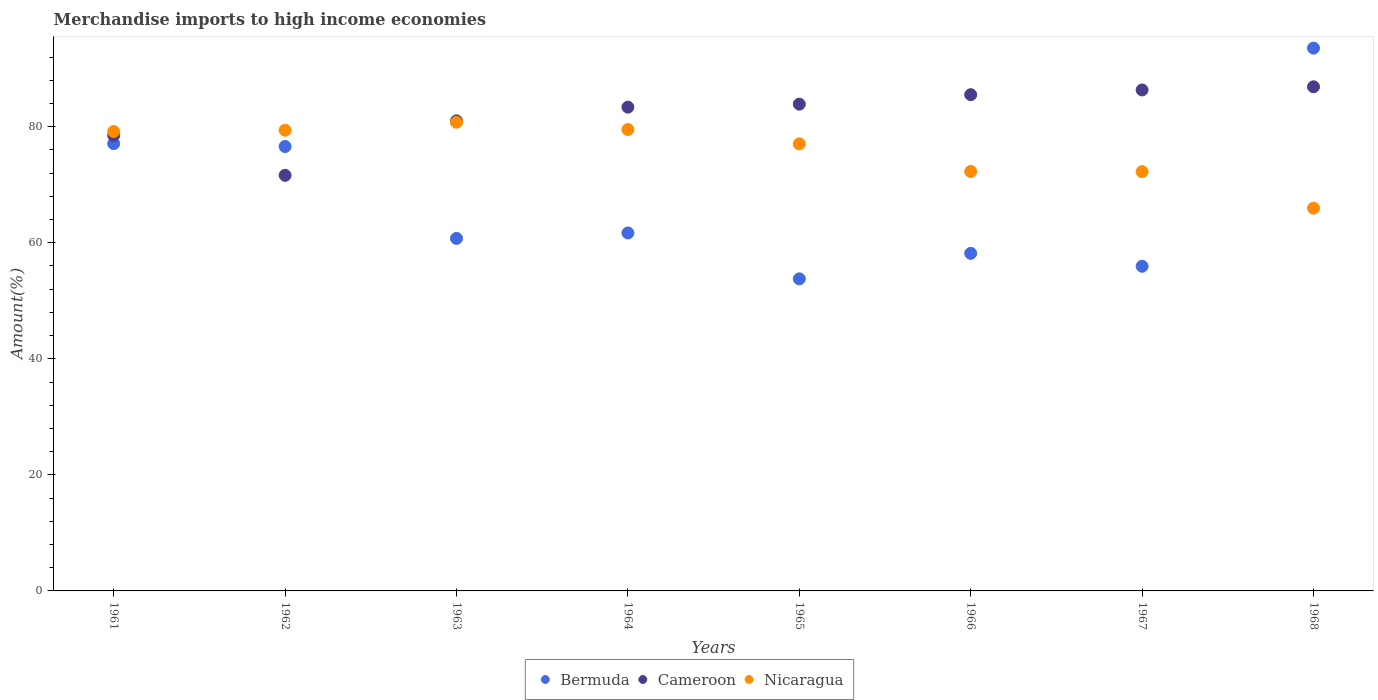What is the percentage of amount earned from merchandise imports in Cameroon in 1965?
Provide a succinct answer. 83.88. Across all years, what is the maximum percentage of amount earned from merchandise imports in Cameroon?
Provide a short and direct response. 86.87. Across all years, what is the minimum percentage of amount earned from merchandise imports in Bermuda?
Your answer should be very brief. 53.78. In which year was the percentage of amount earned from merchandise imports in Bermuda maximum?
Offer a terse response. 1968. In which year was the percentage of amount earned from merchandise imports in Bermuda minimum?
Ensure brevity in your answer.  1965. What is the total percentage of amount earned from merchandise imports in Bermuda in the graph?
Offer a very short reply. 537.51. What is the difference between the percentage of amount earned from merchandise imports in Bermuda in 1964 and that in 1968?
Offer a terse response. -31.85. What is the difference between the percentage of amount earned from merchandise imports in Cameroon in 1962 and the percentage of amount earned from merchandise imports in Nicaragua in 1964?
Make the answer very short. -7.89. What is the average percentage of amount earned from merchandise imports in Bermuda per year?
Offer a very short reply. 67.19. In the year 1965, what is the difference between the percentage of amount earned from merchandise imports in Nicaragua and percentage of amount earned from merchandise imports in Bermuda?
Your response must be concise. 23.25. What is the ratio of the percentage of amount earned from merchandise imports in Bermuda in 1962 to that in 1968?
Keep it short and to the point. 0.82. Is the percentage of amount earned from merchandise imports in Bermuda in 1965 less than that in 1967?
Your answer should be compact. Yes. Is the difference between the percentage of amount earned from merchandise imports in Nicaragua in 1965 and 1966 greater than the difference between the percentage of amount earned from merchandise imports in Bermuda in 1965 and 1966?
Your answer should be compact. Yes. What is the difference between the highest and the second highest percentage of amount earned from merchandise imports in Nicaragua?
Offer a terse response. 1.25. What is the difference between the highest and the lowest percentage of amount earned from merchandise imports in Nicaragua?
Give a very brief answer. 14.8. Is it the case that in every year, the sum of the percentage of amount earned from merchandise imports in Nicaragua and percentage of amount earned from merchandise imports in Bermuda  is greater than the percentage of amount earned from merchandise imports in Cameroon?
Give a very brief answer. Yes. Is the percentage of amount earned from merchandise imports in Cameroon strictly greater than the percentage of amount earned from merchandise imports in Bermuda over the years?
Your answer should be compact. No. Is the percentage of amount earned from merchandise imports in Nicaragua strictly less than the percentage of amount earned from merchandise imports in Cameroon over the years?
Provide a succinct answer. No. How many dotlines are there?
Your response must be concise. 3. What is the difference between two consecutive major ticks on the Y-axis?
Your answer should be very brief. 20. Does the graph contain grids?
Offer a very short reply. No. How many legend labels are there?
Your response must be concise. 3. What is the title of the graph?
Ensure brevity in your answer.  Merchandise imports to high income economies. What is the label or title of the Y-axis?
Offer a very short reply. Amount(%). What is the Amount(%) of Bermuda in 1961?
Give a very brief answer. 77.07. What is the Amount(%) of Cameroon in 1961?
Make the answer very short. 78.49. What is the Amount(%) of Nicaragua in 1961?
Give a very brief answer. 79.17. What is the Amount(%) in Bermuda in 1962?
Provide a succinct answer. 76.58. What is the Amount(%) of Cameroon in 1962?
Give a very brief answer. 71.61. What is the Amount(%) in Nicaragua in 1962?
Offer a very short reply. 79.39. What is the Amount(%) of Bermuda in 1963?
Your answer should be compact. 60.74. What is the Amount(%) in Cameroon in 1963?
Offer a terse response. 81. What is the Amount(%) of Nicaragua in 1963?
Give a very brief answer. 80.76. What is the Amount(%) of Bermuda in 1964?
Your answer should be compact. 61.68. What is the Amount(%) in Cameroon in 1964?
Make the answer very short. 83.36. What is the Amount(%) in Nicaragua in 1964?
Give a very brief answer. 79.5. What is the Amount(%) in Bermuda in 1965?
Keep it short and to the point. 53.78. What is the Amount(%) in Cameroon in 1965?
Your answer should be very brief. 83.88. What is the Amount(%) of Nicaragua in 1965?
Keep it short and to the point. 77.03. What is the Amount(%) in Bermuda in 1966?
Make the answer very short. 58.17. What is the Amount(%) of Cameroon in 1966?
Keep it short and to the point. 85.51. What is the Amount(%) in Nicaragua in 1966?
Ensure brevity in your answer.  72.28. What is the Amount(%) in Bermuda in 1967?
Offer a terse response. 55.94. What is the Amount(%) of Cameroon in 1967?
Your answer should be compact. 86.33. What is the Amount(%) in Nicaragua in 1967?
Make the answer very short. 72.25. What is the Amount(%) in Bermuda in 1968?
Offer a terse response. 93.54. What is the Amount(%) of Cameroon in 1968?
Offer a terse response. 86.87. What is the Amount(%) in Nicaragua in 1968?
Make the answer very short. 65.96. Across all years, what is the maximum Amount(%) in Bermuda?
Ensure brevity in your answer.  93.54. Across all years, what is the maximum Amount(%) in Cameroon?
Give a very brief answer. 86.87. Across all years, what is the maximum Amount(%) of Nicaragua?
Make the answer very short. 80.76. Across all years, what is the minimum Amount(%) of Bermuda?
Ensure brevity in your answer.  53.78. Across all years, what is the minimum Amount(%) of Cameroon?
Give a very brief answer. 71.61. Across all years, what is the minimum Amount(%) in Nicaragua?
Make the answer very short. 65.96. What is the total Amount(%) of Bermuda in the graph?
Provide a succinct answer. 537.51. What is the total Amount(%) in Cameroon in the graph?
Your answer should be very brief. 657.05. What is the total Amount(%) of Nicaragua in the graph?
Make the answer very short. 606.33. What is the difference between the Amount(%) in Bermuda in 1961 and that in 1962?
Offer a very short reply. 0.49. What is the difference between the Amount(%) of Cameroon in 1961 and that in 1962?
Ensure brevity in your answer.  6.88. What is the difference between the Amount(%) of Nicaragua in 1961 and that in 1962?
Your answer should be very brief. -0.22. What is the difference between the Amount(%) in Bermuda in 1961 and that in 1963?
Your response must be concise. 16.33. What is the difference between the Amount(%) of Cameroon in 1961 and that in 1963?
Make the answer very short. -2.51. What is the difference between the Amount(%) in Nicaragua in 1961 and that in 1963?
Your answer should be compact. -1.59. What is the difference between the Amount(%) of Bermuda in 1961 and that in 1964?
Offer a terse response. 15.39. What is the difference between the Amount(%) in Cameroon in 1961 and that in 1964?
Provide a short and direct response. -4.87. What is the difference between the Amount(%) of Nicaragua in 1961 and that in 1964?
Keep it short and to the point. -0.34. What is the difference between the Amount(%) of Bermuda in 1961 and that in 1965?
Offer a terse response. 23.3. What is the difference between the Amount(%) of Cameroon in 1961 and that in 1965?
Your answer should be compact. -5.39. What is the difference between the Amount(%) of Nicaragua in 1961 and that in 1965?
Provide a short and direct response. 2.14. What is the difference between the Amount(%) of Bermuda in 1961 and that in 1966?
Keep it short and to the point. 18.9. What is the difference between the Amount(%) of Cameroon in 1961 and that in 1966?
Provide a short and direct response. -7.02. What is the difference between the Amount(%) of Nicaragua in 1961 and that in 1966?
Make the answer very short. 6.89. What is the difference between the Amount(%) of Bermuda in 1961 and that in 1967?
Your answer should be very brief. 21.13. What is the difference between the Amount(%) in Cameroon in 1961 and that in 1967?
Your answer should be compact. -7.84. What is the difference between the Amount(%) in Nicaragua in 1961 and that in 1967?
Your answer should be very brief. 6.92. What is the difference between the Amount(%) of Bermuda in 1961 and that in 1968?
Ensure brevity in your answer.  -16.46. What is the difference between the Amount(%) of Cameroon in 1961 and that in 1968?
Keep it short and to the point. -8.38. What is the difference between the Amount(%) in Nicaragua in 1961 and that in 1968?
Your answer should be very brief. 13.21. What is the difference between the Amount(%) in Bermuda in 1962 and that in 1963?
Provide a short and direct response. 15.84. What is the difference between the Amount(%) of Cameroon in 1962 and that in 1963?
Keep it short and to the point. -9.39. What is the difference between the Amount(%) of Nicaragua in 1962 and that in 1963?
Keep it short and to the point. -1.37. What is the difference between the Amount(%) of Bermuda in 1962 and that in 1964?
Provide a succinct answer. 14.9. What is the difference between the Amount(%) of Cameroon in 1962 and that in 1964?
Ensure brevity in your answer.  -11.75. What is the difference between the Amount(%) in Nicaragua in 1962 and that in 1964?
Provide a short and direct response. -0.12. What is the difference between the Amount(%) of Bermuda in 1962 and that in 1965?
Give a very brief answer. 22.8. What is the difference between the Amount(%) in Cameroon in 1962 and that in 1965?
Your response must be concise. -12.27. What is the difference between the Amount(%) of Nicaragua in 1962 and that in 1965?
Offer a very short reply. 2.36. What is the difference between the Amount(%) in Bermuda in 1962 and that in 1966?
Provide a short and direct response. 18.41. What is the difference between the Amount(%) in Cameroon in 1962 and that in 1966?
Provide a short and direct response. -13.9. What is the difference between the Amount(%) of Nicaragua in 1962 and that in 1966?
Your answer should be very brief. 7.11. What is the difference between the Amount(%) in Bermuda in 1962 and that in 1967?
Keep it short and to the point. 20.64. What is the difference between the Amount(%) of Cameroon in 1962 and that in 1967?
Make the answer very short. -14.72. What is the difference between the Amount(%) of Nicaragua in 1962 and that in 1967?
Keep it short and to the point. 7.14. What is the difference between the Amount(%) in Bermuda in 1962 and that in 1968?
Give a very brief answer. -16.95. What is the difference between the Amount(%) of Cameroon in 1962 and that in 1968?
Provide a short and direct response. -15.26. What is the difference between the Amount(%) in Nicaragua in 1962 and that in 1968?
Your response must be concise. 13.43. What is the difference between the Amount(%) in Bermuda in 1963 and that in 1964?
Keep it short and to the point. -0.94. What is the difference between the Amount(%) of Cameroon in 1963 and that in 1964?
Offer a terse response. -2.36. What is the difference between the Amount(%) of Nicaragua in 1963 and that in 1964?
Keep it short and to the point. 1.25. What is the difference between the Amount(%) of Bermuda in 1963 and that in 1965?
Make the answer very short. 6.97. What is the difference between the Amount(%) of Cameroon in 1963 and that in 1965?
Offer a terse response. -2.88. What is the difference between the Amount(%) of Nicaragua in 1963 and that in 1965?
Offer a terse response. 3.73. What is the difference between the Amount(%) in Bermuda in 1963 and that in 1966?
Give a very brief answer. 2.57. What is the difference between the Amount(%) of Cameroon in 1963 and that in 1966?
Offer a terse response. -4.51. What is the difference between the Amount(%) of Nicaragua in 1963 and that in 1966?
Offer a very short reply. 8.48. What is the difference between the Amount(%) of Bermuda in 1963 and that in 1967?
Keep it short and to the point. 4.8. What is the difference between the Amount(%) of Cameroon in 1963 and that in 1967?
Offer a terse response. -5.33. What is the difference between the Amount(%) of Nicaragua in 1963 and that in 1967?
Your response must be concise. 8.51. What is the difference between the Amount(%) in Bermuda in 1963 and that in 1968?
Offer a terse response. -32.79. What is the difference between the Amount(%) of Cameroon in 1963 and that in 1968?
Your response must be concise. -5.87. What is the difference between the Amount(%) of Nicaragua in 1963 and that in 1968?
Keep it short and to the point. 14.8. What is the difference between the Amount(%) of Bermuda in 1964 and that in 1965?
Keep it short and to the point. 7.9. What is the difference between the Amount(%) of Cameroon in 1964 and that in 1965?
Provide a succinct answer. -0.52. What is the difference between the Amount(%) of Nicaragua in 1964 and that in 1965?
Keep it short and to the point. 2.48. What is the difference between the Amount(%) in Bermuda in 1964 and that in 1966?
Provide a short and direct response. 3.51. What is the difference between the Amount(%) of Cameroon in 1964 and that in 1966?
Provide a succinct answer. -2.15. What is the difference between the Amount(%) in Nicaragua in 1964 and that in 1966?
Your response must be concise. 7.23. What is the difference between the Amount(%) of Bermuda in 1964 and that in 1967?
Your response must be concise. 5.74. What is the difference between the Amount(%) of Cameroon in 1964 and that in 1967?
Make the answer very short. -2.97. What is the difference between the Amount(%) in Nicaragua in 1964 and that in 1967?
Your response must be concise. 7.25. What is the difference between the Amount(%) in Bermuda in 1964 and that in 1968?
Give a very brief answer. -31.86. What is the difference between the Amount(%) in Cameroon in 1964 and that in 1968?
Provide a short and direct response. -3.51. What is the difference between the Amount(%) of Nicaragua in 1964 and that in 1968?
Your answer should be compact. 13.55. What is the difference between the Amount(%) of Bermuda in 1965 and that in 1966?
Your response must be concise. -4.39. What is the difference between the Amount(%) in Cameroon in 1965 and that in 1966?
Your response must be concise. -1.63. What is the difference between the Amount(%) of Nicaragua in 1965 and that in 1966?
Give a very brief answer. 4.75. What is the difference between the Amount(%) of Bermuda in 1965 and that in 1967?
Ensure brevity in your answer.  -2.17. What is the difference between the Amount(%) of Cameroon in 1965 and that in 1967?
Your answer should be compact. -2.45. What is the difference between the Amount(%) of Nicaragua in 1965 and that in 1967?
Keep it short and to the point. 4.78. What is the difference between the Amount(%) in Bermuda in 1965 and that in 1968?
Your answer should be very brief. -39.76. What is the difference between the Amount(%) of Cameroon in 1965 and that in 1968?
Ensure brevity in your answer.  -2.99. What is the difference between the Amount(%) of Nicaragua in 1965 and that in 1968?
Offer a very short reply. 11.07. What is the difference between the Amount(%) of Bermuda in 1966 and that in 1967?
Offer a very short reply. 2.23. What is the difference between the Amount(%) of Cameroon in 1966 and that in 1967?
Provide a short and direct response. -0.82. What is the difference between the Amount(%) of Nicaragua in 1966 and that in 1967?
Make the answer very short. 0.03. What is the difference between the Amount(%) of Bermuda in 1966 and that in 1968?
Your answer should be compact. -35.37. What is the difference between the Amount(%) of Cameroon in 1966 and that in 1968?
Your answer should be very brief. -1.36. What is the difference between the Amount(%) in Nicaragua in 1966 and that in 1968?
Your answer should be compact. 6.32. What is the difference between the Amount(%) of Bermuda in 1967 and that in 1968?
Keep it short and to the point. -37.59. What is the difference between the Amount(%) of Cameroon in 1967 and that in 1968?
Offer a terse response. -0.54. What is the difference between the Amount(%) of Nicaragua in 1967 and that in 1968?
Provide a succinct answer. 6.29. What is the difference between the Amount(%) in Bermuda in 1961 and the Amount(%) in Cameroon in 1962?
Provide a short and direct response. 5.46. What is the difference between the Amount(%) in Bermuda in 1961 and the Amount(%) in Nicaragua in 1962?
Your answer should be compact. -2.31. What is the difference between the Amount(%) in Cameroon in 1961 and the Amount(%) in Nicaragua in 1962?
Make the answer very short. -0.9. What is the difference between the Amount(%) of Bermuda in 1961 and the Amount(%) of Cameroon in 1963?
Offer a terse response. -3.93. What is the difference between the Amount(%) of Bermuda in 1961 and the Amount(%) of Nicaragua in 1963?
Ensure brevity in your answer.  -3.68. What is the difference between the Amount(%) in Cameroon in 1961 and the Amount(%) in Nicaragua in 1963?
Give a very brief answer. -2.27. What is the difference between the Amount(%) of Bermuda in 1961 and the Amount(%) of Cameroon in 1964?
Offer a terse response. -6.29. What is the difference between the Amount(%) in Bermuda in 1961 and the Amount(%) in Nicaragua in 1964?
Give a very brief answer. -2.43. What is the difference between the Amount(%) in Cameroon in 1961 and the Amount(%) in Nicaragua in 1964?
Offer a very short reply. -1.01. What is the difference between the Amount(%) of Bermuda in 1961 and the Amount(%) of Cameroon in 1965?
Your response must be concise. -6.8. What is the difference between the Amount(%) of Bermuda in 1961 and the Amount(%) of Nicaragua in 1965?
Give a very brief answer. 0.05. What is the difference between the Amount(%) of Cameroon in 1961 and the Amount(%) of Nicaragua in 1965?
Offer a very short reply. 1.46. What is the difference between the Amount(%) of Bermuda in 1961 and the Amount(%) of Cameroon in 1966?
Offer a terse response. -8.43. What is the difference between the Amount(%) in Bermuda in 1961 and the Amount(%) in Nicaragua in 1966?
Make the answer very short. 4.8. What is the difference between the Amount(%) of Cameroon in 1961 and the Amount(%) of Nicaragua in 1966?
Offer a terse response. 6.21. What is the difference between the Amount(%) in Bermuda in 1961 and the Amount(%) in Cameroon in 1967?
Keep it short and to the point. -9.25. What is the difference between the Amount(%) in Bermuda in 1961 and the Amount(%) in Nicaragua in 1967?
Your response must be concise. 4.83. What is the difference between the Amount(%) of Cameroon in 1961 and the Amount(%) of Nicaragua in 1967?
Your answer should be very brief. 6.24. What is the difference between the Amount(%) of Bermuda in 1961 and the Amount(%) of Cameroon in 1968?
Your answer should be compact. -9.8. What is the difference between the Amount(%) in Bermuda in 1961 and the Amount(%) in Nicaragua in 1968?
Provide a short and direct response. 11.12. What is the difference between the Amount(%) of Cameroon in 1961 and the Amount(%) of Nicaragua in 1968?
Ensure brevity in your answer.  12.53. What is the difference between the Amount(%) of Bermuda in 1962 and the Amount(%) of Cameroon in 1963?
Provide a succinct answer. -4.42. What is the difference between the Amount(%) of Bermuda in 1962 and the Amount(%) of Nicaragua in 1963?
Provide a short and direct response. -4.18. What is the difference between the Amount(%) of Cameroon in 1962 and the Amount(%) of Nicaragua in 1963?
Provide a short and direct response. -9.15. What is the difference between the Amount(%) in Bermuda in 1962 and the Amount(%) in Cameroon in 1964?
Offer a terse response. -6.78. What is the difference between the Amount(%) in Bermuda in 1962 and the Amount(%) in Nicaragua in 1964?
Your answer should be very brief. -2.92. What is the difference between the Amount(%) in Cameroon in 1962 and the Amount(%) in Nicaragua in 1964?
Keep it short and to the point. -7.89. What is the difference between the Amount(%) in Bermuda in 1962 and the Amount(%) in Cameroon in 1965?
Give a very brief answer. -7.29. What is the difference between the Amount(%) of Bermuda in 1962 and the Amount(%) of Nicaragua in 1965?
Your answer should be compact. -0.45. What is the difference between the Amount(%) in Cameroon in 1962 and the Amount(%) in Nicaragua in 1965?
Your answer should be compact. -5.42. What is the difference between the Amount(%) of Bermuda in 1962 and the Amount(%) of Cameroon in 1966?
Ensure brevity in your answer.  -8.92. What is the difference between the Amount(%) of Bermuda in 1962 and the Amount(%) of Nicaragua in 1966?
Your response must be concise. 4.31. What is the difference between the Amount(%) in Cameroon in 1962 and the Amount(%) in Nicaragua in 1966?
Ensure brevity in your answer.  -0.67. What is the difference between the Amount(%) of Bermuda in 1962 and the Amount(%) of Cameroon in 1967?
Provide a short and direct response. -9.74. What is the difference between the Amount(%) in Bermuda in 1962 and the Amount(%) in Nicaragua in 1967?
Your answer should be very brief. 4.33. What is the difference between the Amount(%) in Cameroon in 1962 and the Amount(%) in Nicaragua in 1967?
Ensure brevity in your answer.  -0.64. What is the difference between the Amount(%) in Bermuda in 1962 and the Amount(%) in Cameroon in 1968?
Provide a short and direct response. -10.29. What is the difference between the Amount(%) in Bermuda in 1962 and the Amount(%) in Nicaragua in 1968?
Offer a terse response. 10.63. What is the difference between the Amount(%) in Cameroon in 1962 and the Amount(%) in Nicaragua in 1968?
Keep it short and to the point. 5.65. What is the difference between the Amount(%) in Bermuda in 1963 and the Amount(%) in Cameroon in 1964?
Your answer should be compact. -22.62. What is the difference between the Amount(%) of Bermuda in 1963 and the Amount(%) of Nicaragua in 1964?
Your response must be concise. -18.76. What is the difference between the Amount(%) of Cameroon in 1963 and the Amount(%) of Nicaragua in 1964?
Make the answer very short. 1.5. What is the difference between the Amount(%) in Bermuda in 1963 and the Amount(%) in Cameroon in 1965?
Keep it short and to the point. -23.13. What is the difference between the Amount(%) in Bermuda in 1963 and the Amount(%) in Nicaragua in 1965?
Provide a succinct answer. -16.28. What is the difference between the Amount(%) in Cameroon in 1963 and the Amount(%) in Nicaragua in 1965?
Keep it short and to the point. 3.97. What is the difference between the Amount(%) in Bermuda in 1963 and the Amount(%) in Cameroon in 1966?
Keep it short and to the point. -24.76. What is the difference between the Amount(%) of Bermuda in 1963 and the Amount(%) of Nicaragua in 1966?
Give a very brief answer. -11.53. What is the difference between the Amount(%) of Cameroon in 1963 and the Amount(%) of Nicaragua in 1966?
Your answer should be very brief. 8.72. What is the difference between the Amount(%) of Bermuda in 1963 and the Amount(%) of Cameroon in 1967?
Your response must be concise. -25.58. What is the difference between the Amount(%) of Bermuda in 1963 and the Amount(%) of Nicaragua in 1967?
Provide a succinct answer. -11.51. What is the difference between the Amount(%) of Cameroon in 1963 and the Amount(%) of Nicaragua in 1967?
Ensure brevity in your answer.  8.75. What is the difference between the Amount(%) of Bermuda in 1963 and the Amount(%) of Cameroon in 1968?
Your answer should be compact. -26.13. What is the difference between the Amount(%) of Bermuda in 1963 and the Amount(%) of Nicaragua in 1968?
Keep it short and to the point. -5.21. What is the difference between the Amount(%) in Cameroon in 1963 and the Amount(%) in Nicaragua in 1968?
Offer a very short reply. 15.04. What is the difference between the Amount(%) in Bermuda in 1964 and the Amount(%) in Cameroon in 1965?
Offer a very short reply. -22.2. What is the difference between the Amount(%) in Bermuda in 1964 and the Amount(%) in Nicaragua in 1965?
Your answer should be very brief. -15.35. What is the difference between the Amount(%) of Cameroon in 1964 and the Amount(%) of Nicaragua in 1965?
Your response must be concise. 6.33. What is the difference between the Amount(%) of Bermuda in 1964 and the Amount(%) of Cameroon in 1966?
Ensure brevity in your answer.  -23.83. What is the difference between the Amount(%) in Bermuda in 1964 and the Amount(%) in Nicaragua in 1966?
Give a very brief answer. -10.6. What is the difference between the Amount(%) of Cameroon in 1964 and the Amount(%) of Nicaragua in 1966?
Offer a very short reply. 11.08. What is the difference between the Amount(%) of Bermuda in 1964 and the Amount(%) of Cameroon in 1967?
Your answer should be very brief. -24.65. What is the difference between the Amount(%) of Bermuda in 1964 and the Amount(%) of Nicaragua in 1967?
Provide a succinct answer. -10.57. What is the difference between the Amount(%) of Cameroon in 1964 and the Amount(%) of Nicaragua in 1967?
Make the answer very short. 11.11. What is the difference between the Amount(%) in Bermuda in 1964 and the Amount(%) in Cameroon in 1968?
Your answer should be compact. -25.19. What is the difference between the Amount(%) in Bermuda in 1964 and the Amount(%) in Nicaragua in 1968?
Keep it short and to the point. -4.28. What is the difference between the Amount(%) of Cameroon in 1964 and the Amount(%) of Nicaragua in 1968?
Keep it short and to the point. 17.4. What is the difference between the Amount(%) in Bermuda in 1965 and the Amount(%) in Cameroon in 1966?
Give a very brief answer. -31.73. What is the difference between the Amount(%) in Bermuda in 1965 and the Amount(%) in Nicaragua in 1966?
Offer a very short reply. -18.5. What is the difference between the Amount(%) in Cameroon in 1965 and the Amount(%) in Nicaragua in 1966?
Make the answer very short. 11.6. What is the difference between the Amount(%) in Bermuda in 1965 and the Amount(%) in Cameroon in 1967?
Your answer should be compact. -32.55. What is the difference between the Amount(%) in Bermuda in 1965 and the Amount(%) in Nicaragua in 1967?
Your response must be concise. -18.47. What is the difference between the Amount(%) in Cameroon in 1965 and the Amount(%) in Nicaragua in 1967?
Keep it short and to the point. 11.63. What is the difference between the Amount(%) of Bermuda in 1965 and the Amount(%) of Cameroon in 1968?
Your answer should be very brief. -33.09. What is the difference between the Amount(%) of Bermuda in 1965 and the Amount(%) of Nicaragua in 1968?
Keep it short and to the point. -12.18. What is the difference between the Amount(%) in Cameroon in 1965 and the Amount(%) in Nicaragua in 1968?
Provide a short and direct response. 17.92. What is the difference between the Amount(%) of Bermuda in 1966 and the Amount(%) of Cameroon in 1967?
Ensure brevity in your answer.  -28.16. What is the difference between the Amount(%) in Bermuda in 1966 and the Amount(%) in Nicaragua in 1967?
Provide a succinct answer. -14.08. What is the difference between the Amount(%) in Cameroon in 1966 and the Amount(%) in Nicaragua in 1967?
Ensure brevity in your answer.  13.26. What is the difference between the Amount(%) of Bermuda in 1966 and the Amount(%) of Cameroon in 1968?
Offer a terse response. -28.7. What is the difference between the Amount(%) of Bermuda in 1966 and the Amount(%) of Nicaragua in 1968?
Your answer should be compact. -7.79. What is the difference between the Amount(%) in Cameroon in 1966 and the Amount(%) in Nicaragua in 1968?
Keep it short and to the point. 19.55. What is the difference between the Amount(%) in Bermuda in 1967 and the Amount(%) in Cameroon in 1968?
Your answer should be compact. -30.93. What is the difference between the Amount(%) of Bermuda in 1967 and the Amount(%) of Nicaragua in 1968?
Provide a succinct answer. -10.01. What is the difference between the Amount(%) of Cameroon in 1967 and the Amount(%) of Nicaragua in 1968?
Ensure brevity in your answer.  20.37. What is the average Amount(%) in Bermuda per year?
Provide a short and direct response. 67.19. What is the average Amount(%) in Cameroon per year?
Ensure brevity in your answer.  82.13. What is the average Amount(%) of Nicaragua per year?
Give a very brief answer. 75.79. In the year 1961, what is the difference between the Amount(%) of Bermuda and Amount(%) of Cameroon?
Your answer should be compact. -1.41. In the year 1961, what is the difference between the Amount(%) in Bermuda and Amount(%) in Nicaragua?
Make the answer very short. -2.09. In the year 1961, what is the difference between the Amount(%) of Cameroon and Amount(%) of Nicaragua?
Your answer should be very brief. -0.68. In the year 1962, what is the difference between the Amount(%) of Bermuda and Amount(%) of Cameroon?
Keep it short and to the point. 4.97. In the year 1962, what is the difference between the Amount(%) in Bermuda and Amount(%) in Nicaragua?
Offer a terse response. -2.8. In the year 1962, what is the difference between the Amount(%) of Cameroon and Amount(%) of Nicaragua?
Provide a short and direct response. -7.78. In the year 1963, what is the difference between the Amount(%) of Bermuda and Amount(%) of Cameroon?
Offer a terse response. -20.26. In the year 1963, what is the difference between the Amount(%) in Bermuda and Amount(%) in Nicaragua?
Your response must be concise. -20.01. In the year 1963, what is the difference between the Amount(%) in Cameroon and Amount(%) in Nicaragua?
Make the answer very short. 0.24. In the year 1964, what is the difference between the Amount(%) in Bermuda and Amount(%) in Cameroon?
Offer a very short reply. -21.68. In the year 1964, what is the difference between the Amount(%) of Bermuda and Amount(%) of Nicaragua?
Make the answer very short. -17.82. In the year 1964, what is the difference between the Amount(%) in Cameroon and Amount(%) in Nicaragua?
Provide a short and direct response. 3.86. In the year 1965, what is the difference between the Amount(%) of Bermuda and Amount(%) of Cameroon?
Your answer should be very brief. -30.1. In the year 1965, what is the difference between the Amount(%) of Bermuda and Amount(%) of Nicaragua?
Give a very brief answer. -23.25. In the year 1965, what is the difference between the Amount(%) in Cameroon and Amount(%) in Nicaragua?
Provide a short and direct response. 6.85. In the year 1966, what is the difference between the Amount(%) of Bermuda and Amount(%) of Cameroon?
Your response must be concise. -27.34. In the year 1966, what is the difference between the Amount(%) of Bermuda and Amount(%) of Nicaragua?
Give a very brief answer. -14.11. In the year 1966, what is the difference between the Amount(%) in Cameroon and Amount(%) in Nicaragua?
Your answer should be very brief. 13.23. In the year 1967, what is the difference between the Amount(%) of Bermuda and Amount(%) of Cameroon?
Offer a very short reply. -30.38. In the year 1967, what is the difference between the Amount(%) in Bermuda and Amount(%) in Nicaragua?
Make the answer very short. -16.31. In the year 1967, what is the difference between the Amount(%) of Cameroon and Amount(%) of Nicaragua?
Make the answer very short. 14.08. In the year 1968, what is the difference between the Amount(%) of Bermuda and Amount(%) of Cameroon?
Offer a terse response. 6.66. In the year 1968, what is the difference between the Amount(%) in Bermuda and Amount(%) in Nicaragua?
Give a very brief answer. 27.58. In the year 1968, what is the difference between the Amount(%) in Cameroon and Amount(%) in Nicaragua?
Your answer should be very brief. 20.91. What is the ratio of the Amount(%) of Bermuda in 1961 to that in 1962?
Your answer should be very brief. 1.01. What is the ratio of the Amount(%) in Cameroon in 1961 to that in 1962?
Your answer should be compact. 1.1. What is the ratio of the Amount(%) in Bermuda in 1961 to that in 1963?
Give a very brief answer. 1.27. What is the ratio of the Amount(%) in Cameroon in 1961 to that in 1963?
Offer a very short reply. 0.97. What is the ratio of the Amount(%) of Nicaragua in 1961 to that in 1963?
Ensure brevity in your answer.  0.98. What is the ratio of the Amount(%) of Bermuda in 1961 to that in 1964?
Your response must be concise. 1.25. What is the ratio of the Amount(%) of Cameroon in 1961 to that in 1964?
Provide a succinct answer. 0.94. What is the ratio of the Amount(%) in Bermuda in 1961 to that in 1965?
Ensure brevity in your answer.  1.43. What is the ratio of the Amount(%) of Cameroon in 1961 to that in 1965?
Give a very brief answer. 0.94. What is the ratio of the Amount(%) in Nicaragua in 1961 to that in 1965?
Your response must be concise. 1.03. What is the ratio of the Amount(%) in Bermuda in 1961 to that in 1966?
Offer a very short reply. 1.32. What is the ratio of the Amount(%) of Cameroon in 1961 to that in 1966?
Ensure brevity in your answer.  0.92. What is the ratio of the Amount(%) of Nicaragua in 1961 to that in 1966?
Offer a terse response. 1.1. What is the ratio of the Amount(%) of Bermuda in 1961 to that in 1967?
Offer a very short reply. 1.38. What is the ratio of the Amount(%) in Cameroon in 1961 to that in 1967?
Provide a succinct answer. 0.91. What is the ratio of the Amount(%) of Nicaragua in 1961 to that in 1967?
Give a very brief answer. 1.1. What is the ratio of the Amount(%) in Bermuda in 1961 to that in 1968?
Provide a succinct answer. 0.82. What is the ratio of the Amount(%) of Cameroon in 1961 to that in 1968?
Provide a short and direct response. 0.9. What is the ratio of the Amount(%) in Nicaragua in 1961 to that in 1968?
Your answer should be compact. 1.2. What is the ratio of the Amount(%) of Bermuda in 1962 to that in 1963?
Your answer should be compact. 1.26. What is the ratio of the Amount(%) of Cameroon in 1962 to that in 1963?
Make the answer very short. 0.88. What is the ratio of the Amount(%) in Bermuda in 1962 to that in 1964?
Keep it short and to the point. 1.24. What is the ratio of the Amount(%) in Cameroon in 1962 to that in 1964?
Keep it short and to the point. 0.86. What is the ratio of the Amount(%) of Nicaragua in 1962 to that in 1964?
Keep it short and to the point. 1. What is the ratio of the Amount(%) of Bermuda in 1962 to that in 1965?
Your answer should be compact. 1.42. What is the ratio of the Amount(%) of Cameroon in 1962 to that in 1965?
Provide a succinct answer. 0.85. What is the ratio of the Amount(%) of Nicaragua in 1962 to that in 1965?
Keep it short and to the point. 1.03. What is the ratio of the Amount(%) of Bermuda in 1962 to that in 1966?
Provide a short and direct response. 1.32. What is the ratio of the Amount(%) of Cameroon in 1962 to that in 1966?
Give a very brief answer. 0.84. What is the ratio of the Amount(%) in Nicaragua in 1962 to that in 1966?
Offer a terse response. 1.1. What is the ratio of the Amount(%) in Bermuda in 1962 to that in 1967?
Make the answer very short. 1.37. What is the ratio of the Amount(%) of Cameroon in 1962 to that in 1967?
Offer a terse response. 0.83. What is the ratio of the Amount(%) in Nicaragua in 1962 to that in 1967?
Keep it short and to the point. 1.1. What is the ratio of the Amount(%) of Bermuda in 1962 to that in 1968?
Provide a succinct answer. 0.82. What is the ratio of the Amount(%) in Cameroon in 1962 to that in 1968?
Provide a short and direct response. 0.82. What is the ratio of the Amount(%) of Nicaragua in 1962 to that in 1968?
Offer a terse response. 1.2. What is the ratio of the Amount(%) of Bermuda in 1963 to that in 1964?
Provide a succinct answer. 0.98. What is the ratio of the Amount(%) of Cameroon in 1963 to that in 1964?
Your response must be concise. 0.97. What is the ratio of the Amount(%) of Nicaragua in 1963 to that in 1964?
Ensure brevity in your answer.  1.02. What is the ratio of the Amount(%) of Bermuda in 1963 to that in 1965?
Make the answer very short. 1.13. What is the ratio of the Amount(%) of Cameroon in 1963 to that in 1965?
Your answer should be compact. 0.97. What is the ratio of the Amount(%) of Nicaragua in 1963 to that in 1965?
Keep it short and to the point. 1.05. What is the ratio of the Amount(%) of Bermuda in 1963 to that in 1966?
Offer a terse response. 1.04. What is the ratio of the Amount(%) of Cameroon in 1963 to that in 1966?
Provide a short and direct response. 0.95. What is the ratio of the Amount(%) in Nicaragua in 1963 to that in 1966?
Your response must be concise. 1.12. What is the ratio of the Amount(%) of Bermuda in 1963 to that in 1967?
Ensure brevity in your answer.  1.09. What is the ratio of the Amount(%) in Cameroon in 1963 to that in 1967?
Provide a succinct answer. 0.94. What is the ratio of the Amount(%) of Nicaragua in 1963 to that in 1967?
Give a very brief answer. 1.12. What is the ratio of the Amount(%) of Bermuda in 1963 to that in 1968?
Your response must be concise. 0.65. What is the ratio of the Amount(%) of Cameroon in 1963 to that in 1968?
Your response must be concise. 0.93. What is the ratio of the Amount(%) of Nicaragua in 1963 to that in 1968?
Make the answer very short. 1.22. What is the ratio of the Amount(%) in Bermuda in 1964 to that in 1965?
Provide a succinct answer. 1.15. What is the ratio of the Amount(%) of Nicaragua in 1964 to that in 1965?
Offer a very short reply. 1.03. What is the ratio of the Amount(%) in Bermuda in 1964 to that in 1966?
Your answer should be compact. 1.06. What is the ratio of the Amount(%) in Cameroon in 1964 to that in 1966?
Your response must be concise. 0.97. What is the ratio of the Amount(%) of Nicaragua in 1964 to that in 1966?
Your response must be concise. 1.1. What is the ratio of the Amount(%) of Bermuda in 1964 to that in 1967?
Make the answer very short. 1.1. What is the ratio of the Amount(%) of Cameroon in 1964 to that in 1967?
Give a very brief answer. 0.97. What is the ratio of the Amount(%) in Nicaragua in 1964 to that in 1967?
Provide a succinct answer. 1.1. What is the ratio of the Amount(%) in Bermuda in 1964 to that in 1968?
Ensure brevity in your answer.  0.66. What is the ratio of the Amount(%) in Cameroon in 1964 to that in 1968?
Provide a short and direct response. 0.96. What is the ratio of the Amount(%) of Nicaragua in 1964 to that in 1968?
Provide a succinct answer. 1.21. What is the ratio of the Amount(%) of Bermuda in 1965 to that in 1966?
Keep it short and to the point. 0.92. What is the ratio of the Amount(%) in Cameroon in 1965 to that in 1966?
Offer a very short reply. 0.98. What is the ratio of the Amount(%) of Nicaragua in 1965 to that in 1966?
Make the answer very short. 1.07. What is the ratio of the Amount(%) in Bermuda in 1965 to that in 1967?
Give a very brief answer. 0.96. What is the ratio of the Amount(%) in Cameroon in 1965 to that in 1967?
Your response must be concise. 0.97. What is the ratio of the Amount(%) in Nicaragua in 1965 to that in 1967?
Provide a short and direct response. 1.07. What is the ratio of the Amount(%) of Bermuda in 1965 to that in 1968?
Make the answer very short. 0.57. What is the ratio of the Amount(%) in Cameroon in 1965 to that in 1968?
Make the answer very short. 0.97. What is the ratio of the Amount(%) in Nicaragua in 1965 to that in 1968?
Offer a very short reply. 1.17. What is the ratio of the Amount(%) in Bermuda in 1966 to that in 1967?
Give a very brief answer. 1.04. What is the ratio of the Amount(%) in Cameroon in 1966 to that in 1967?
Your answer should be very brief. 0.99. What is the ratio of the Amount(%) of Bermuda in 1966 to that in 1968?
Ensure brevity in your answer.  0.62. What is the ratio of the Amount(%) of Cameroon in 1966 to that in 1968?
Offer a very short reply. 0.98. What is the ratio of the Amount(%) in Nicaragua in 1966 to that in 1968?
Your response must be concise. 1.1. What is the ratio of the Amount(%) of Bermuda in 1967 to that in 1968?
Provide a short and direct response. 0.6. What is the ratio of the Amount(%) of Nicaragua in 1967 to that in 1968?
Provide a succinct answer. 1.1. What is the difference between the highest and the second highest Amount(%) of Bermuda?
Your response must be concise. 16.46. What is the difference between the highest and the second highest Amount(%) in Cameroon?
Offer a very short reply. 0.54. What is the difference between the highest and the second highest Amount(%) of Nicaragua?
Keep it short and to the point. 1.25. What is the difference between the highest and the lowest Amount(%) in Bermuda?
Your answer should be very brief. 39.76. What is the difference between the highest and the lowest Amount(%) in Cameroon?
Provide a succinct answer. 15.26. What is the difference between the highest and the lowest Amount(%) of Nicaragua?
Provide a short and direct response. 14.8. 